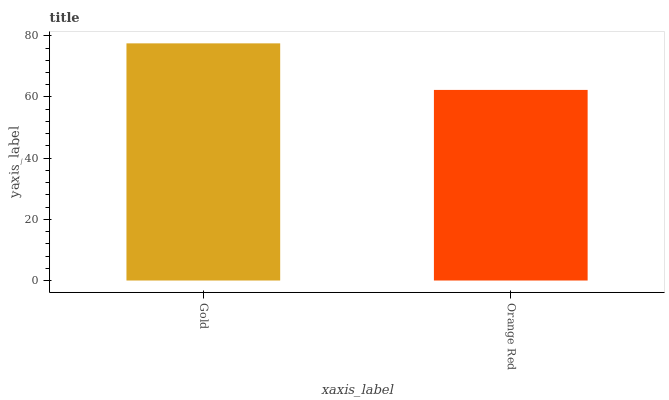Is Orange Red the minimum?
Answer yes or no. Yes. Is Gold the maximum?
Answer yes or no. Yes. Is Orange Red the maximum?
Answer yes or no. No. Is Gold greater than Orange Red?
Answer yes or no. Yes. Is Orange Red less than Gold?
Answer yes or no. Yes. Is Orange Red greater than Gold?
Answer yes or no. No. Is Gold less than Orange Red?
Answer yes or no. No. Is Gold the high median?
Answer yes or no. Yes. Is Orange Red the low median?
Answer yes or no. Yes. Is Orange Red the high median?
Answer yes or no. No. Is Gold the low median?
Answer yes or no. No. 